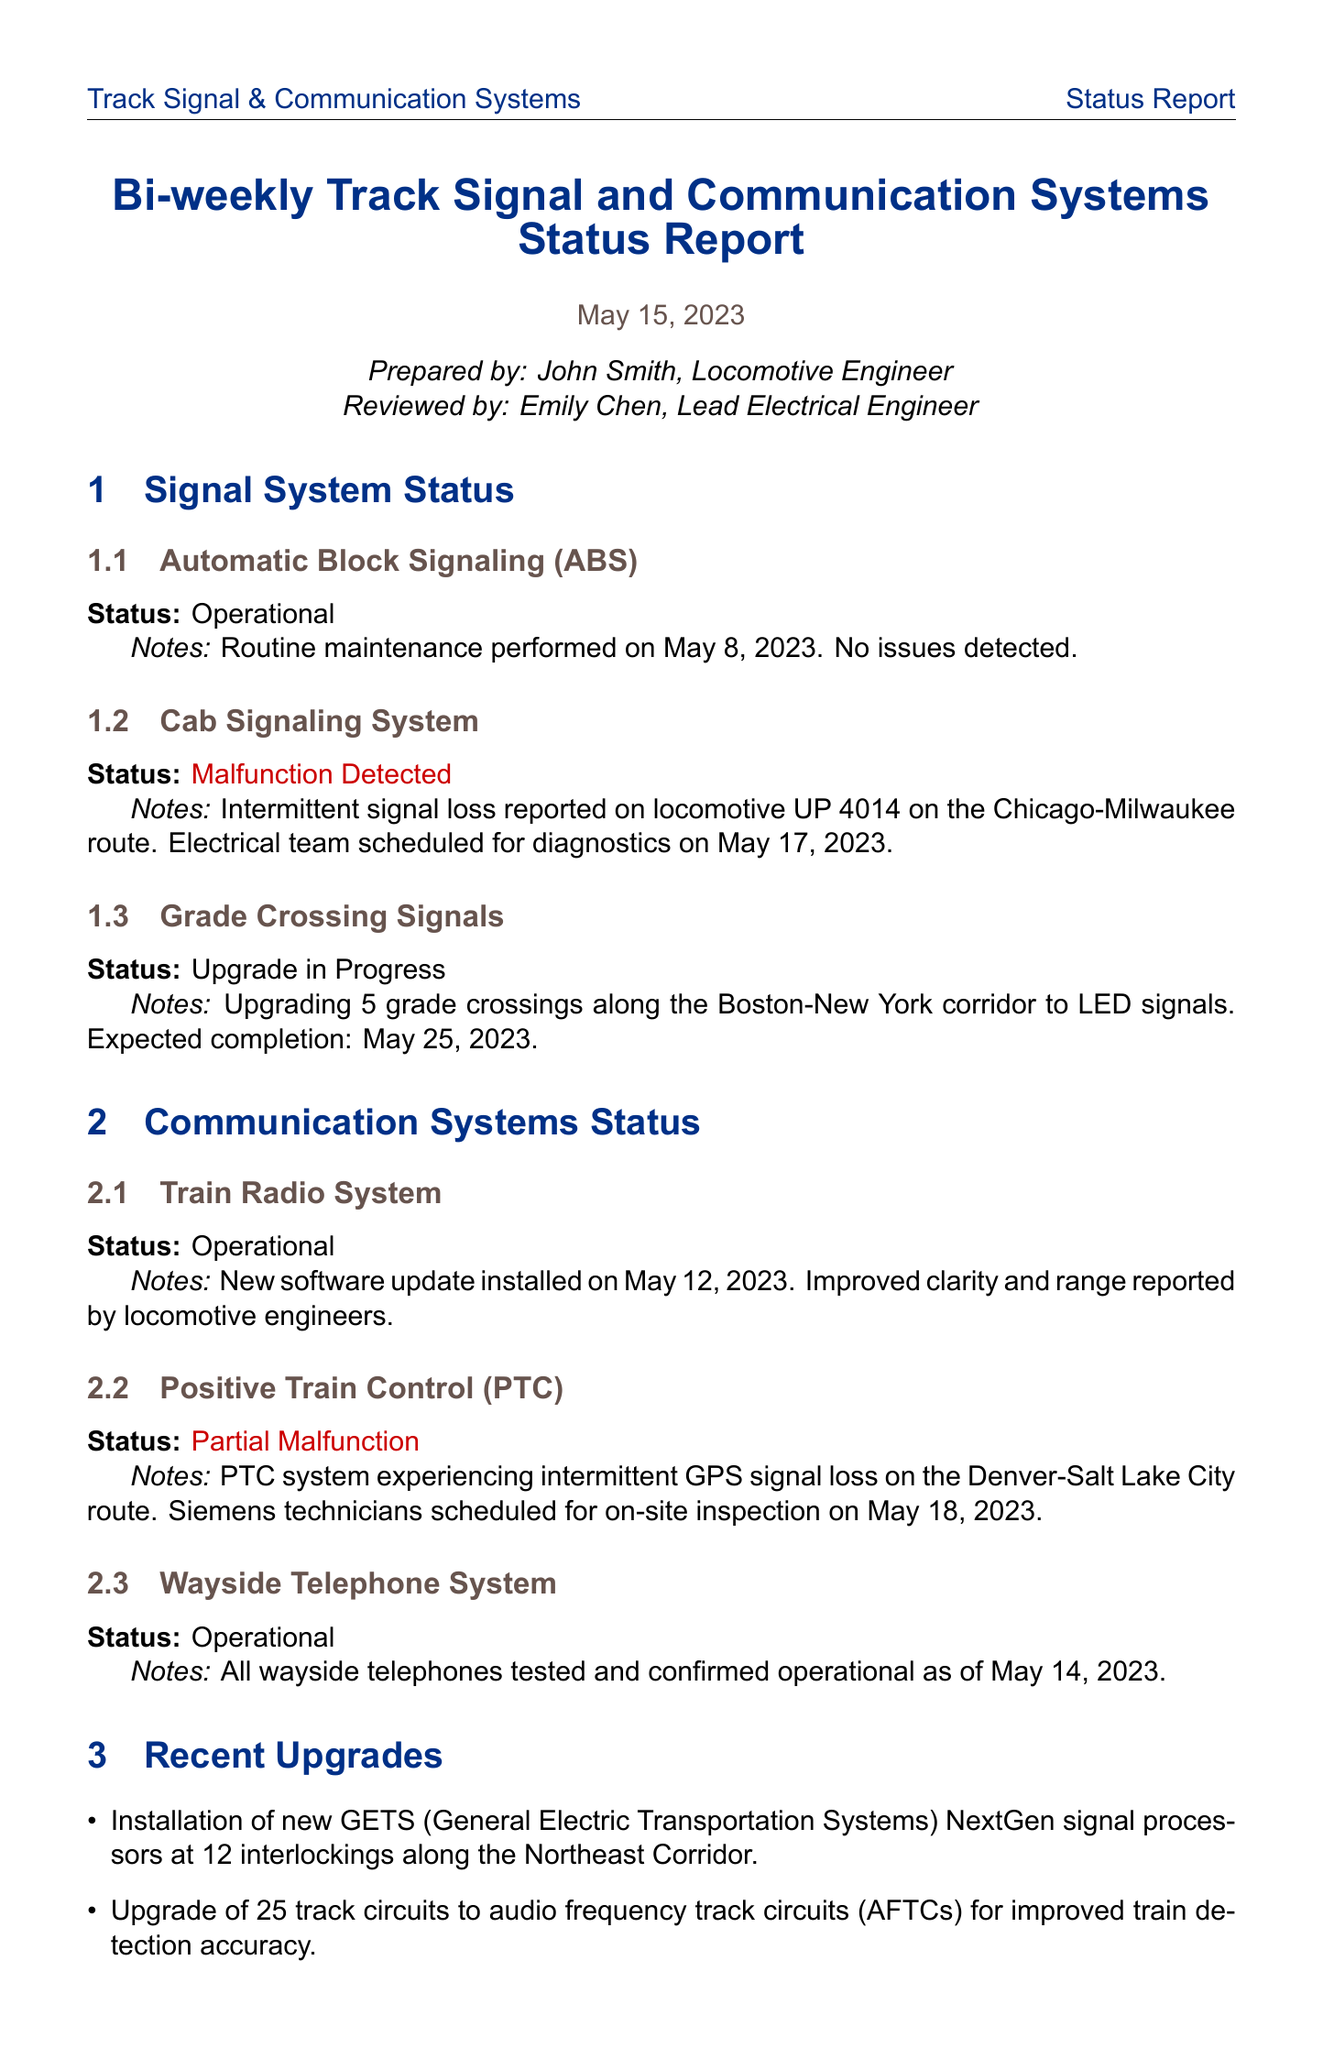What is the report's title? The title is located at the beginning of the report and states the nature of the report.
Answer: Bi-weekly Track Signal and Communication Systems Status Report Who prepared the report? The name of the individual who prepared the report is listed in the document.
Answer: John Smith What was the status of the Automatic Block Signaling (ABS)? The status of ABS is explicitly mentioned in the status section of the report.
Answer: Operational When is the scheduled diagnostic for the Cab Signaling System? The date for the diagnostics of the Cab Signaling System is provided in the report's notes.
Answer: May 17, 2023 What upgrade is currently in progress? The report mentions a specific upgrade that is ongoing.
Answer: Upgrading 5 grade crossings to LED signals How many track circuits were upgraded to audio frequency track circuits? The number of track circuits that were upgraded is stated under the recent upgrades section.
Answer: 25 What is recommended for PTC system checks? The report includes a recommendation regarding the frequency of checks for the PTC system on specific routes.
Answer: Increase frequency What are the dates for the scheduled battery replacements? The dates for the scheduled replacements are specifically listed in the upcoming maintenance section.
Answer: May 22-23, 2023 How many attachments are included in the report? The total number of attachments mentioned at the end of the document provides this information.
Answer: 4 